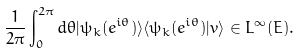Convert formula to latex. <formula><loc_0><loc_0><loc_500><loc_500>\frac { 1 } { 2 \pi } \int _ { 0 } ^ { 2 \pi } d \theta | \psi _ { k } ( e ^ { i \theta } ) \rangle \langle \psi _ { k } ( e ^ { i \theta } ) | v \rangle \in L ^ { \infty } ( E ) .</formula> 